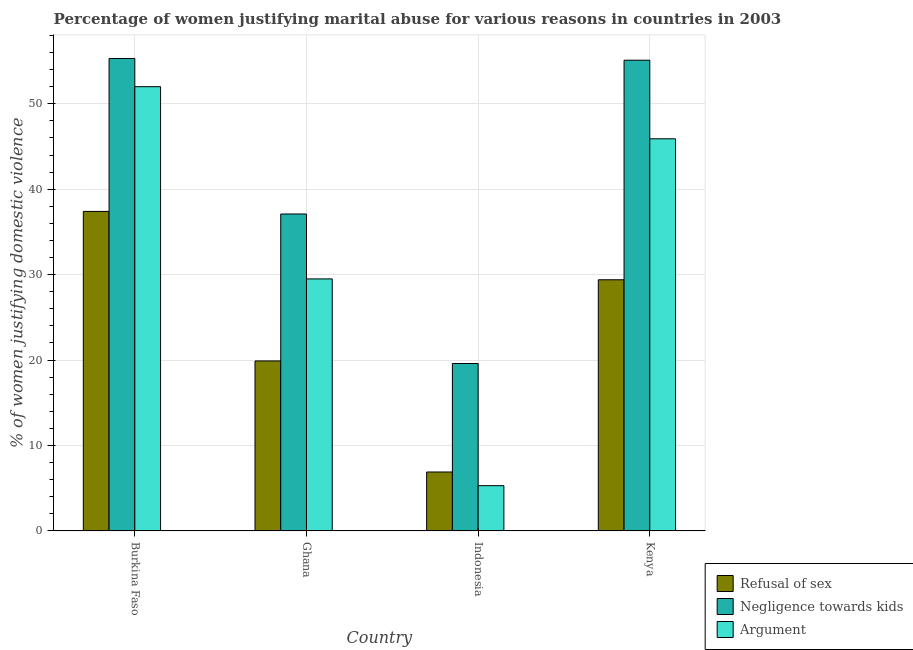Are the number of bars per tick equal to the number of legend labels?
Your response must be concise. Yes. Are the number of bars on each tick of the X-axis equal?
Your response must be concise. Yes. How many bars are there on the 1st tick from the left?
Provide a short and direct response. 3. How many bars are there on the 4th tick from the right?
Offer a very short reply. 3. What is the label of the 2nd group of bars from the left?
Make the answer very short. Ghana. Across all countries, what is the maximum percentage of women justifying domestic violence due to refusal of sex?
Provide a short and direct response. 37.4. In which country was the percentage of women justifying domestic violence due to refusal of sex maximum?
Provide a short and direct response. Burkina Faso. What is the total percentage of women justifying domestic violence due to refusal of sex in the graph?
Ensure brevity in your answer.  93.6. What is the difference between the percentage of women justifying domestic violence due to refusal of sex in Ghana and that in Kenya?
Offer a terse response. -9.5. What is the difference between the percentage of women justifying domestic violence due to arguments in Burkina Faso and the percentage of women justifying domestic violence due to negligence towards kids in Kenya?
Keep it short and to the point. -3.1. What is the average percentage of women justifying domestic violence due to negligence towards kids per country?
Your response must be concise. 41.77. What is the difference between the percentage of women justifying domestic violence due to refusal of sex and percentage of women justifying domestic violence due to negligence towards kids in Kenya?
Give a very brief answer. -25.7. What is the ratio of the percentage of women justifying domestic violence due to negligence towards kids in Indonesia to that in Kenya?
Offer a terse response. 0.36. Is the percentage of women justifying domestic violence due to negligence towards kids in Burkina Faso less than that in Indonesia?
Ensure brevity in your answer.  No. What is the difference between the highest and the second highest percentage of women justifying domestic violence due to negligence towards kids?
Give a very brief answer. 0.2. What is the difference between the highest and the lowest percentage of women justifying domestic violence due to negligence towards kids?
Your answer should be compact. 35.7. In how many countries, is the percentage of women justifying domestic violence due to arguments greater than the average percentage of women justifying domestic violence due to arguments taken over all countries?
Provide a short and direct response. 2. What does the 2nd bar from the left in Ghana represents?
Offer a very short reply. Negligence towards kids. What does the 1st bar from the right in Kenya represents?
Offer a terse response. Argument. Is it the case that in every country, the sum of the percentage of women justifying domestic violence due to refusal of sex and percentage of women justifying domestic violence due to negligence towards kids is greater than the percentage of women justifying domestic violence due to arguments?
Provide a short and direct response. Yes. How many countries are there in the graph?
Offer a very short reply. 4. Does the graph contain any zero values?
Offer a terse response. No. Does the graph contain grids?
Your answer should be compact. Yes. What is the title of the graph?
Provide a succinct answer. Percentage of women justifying marital abuse for various reasons in countries in 2003. Does "Taxes on international trade" appear as one of the legend labels in the graph?
Give a very brief answer. No. What is the label or title of the X-axis?
Provide a short and direct response. Country. What is the label or title of the Y-axis?
Make the answer very short. % of women justifying domestic violence. What is the % of women justifying domestic violence in Refusal of sex in Burkina Faso?
Make the answer very short. 37.4. What is the % of women justifying domestic violence of Negligence towards kids in Burkina Faso?
Give a very brief answer. 55.3. What is the % of women justifying domestic violence of Refusal of sex in Ghana?
Provide a short and direct response. 19.9. What is the % of women justifying domestic violence in Negligence towards kids in Ghana?
Give a very brief answer. 37.1. What is the % of women justifying domestic violence in Argument in Ghana?
Your answer should be compact. 29.5. What is the % of women justifying domestic violence in Negligence towards kids in Indonesia?
Offer a very short reply. 19.6. What is the % of women justifying domestic violence in Refusal of sex in Kenya?
Keep it short and to the point. 29.4. What is the % of women justifying domestic violence of Negligence towards kids in Kenya?
Make the answer very short. 55.1. What is the % of women justifying domestic violence in Argument in Kenya?
Make the answer very short. 45.9. Across all countries, what is the maximum % of women justifying domestic violence in Refusal of sex?
Offer a terse response. 37.4. Across all countries, what is the maximum % of women justifying domestic violence of Negligence towards kids?
Offer a terse response. 55.3. Across all countries, what is the maximum % of women justifying domestic violence of Argument?
Provide a short and direct response. 52. Across all countries, what is the minimum % of women justifying domestic violence in Negligence towards kids?
Offer a terse response. 19.6. Across all countries, what is the minimum % of women justifying domestic violence in Argument?
Make the answer very short. 5.3. What is the total % of women justifying domestic violence in Refusal of sex in the graph?
Provide a short and direct response. 93.6. What is the total % of women justifying domestic violence of Negligence towards kids in the graph?
Keep it short and to the point. 167.1. What is the total % of women justifying domestic violence of Argument in the graph?
Your answer should be very brief. 132.7. What is the difference between the % of women justifying domestic violence of Refusal of sex in Burkina Faso and that in Ghana?
Offer a very short reply. 17.5. What is the difference between the % of women justifying domestic violence in Negligence towards kids in Burkina Faso and that in Ghana?
Ensure brevity in your answer.  18.2. What is the difference between the % of women justifying domestic violence in Refusal of sex in Burkina Faso and that in Indonesia?
Your answer should be very brief. 30.5. What is the difference between the % of women justifying domestic violence in Negligence towards kids in Burkina Faso and that in Indonesia?
Provide a succinct answer. 35.7. What is the difference between the % of women justifying domestic violence of Argument in Burkina Faso and that in Indonesia?
Give a very brief answer. 46.7. What is the difference between the % of women justifying domestic violence in Argument in Burkina Faso and that in Kenya?
Make the answer very short. 6.1. What is the difference between the % of women justifying domestic violence of Refusal of sex in Ghana and that in Indonesia?
Keep it short and to the point. 13. What is the difference between the % of women justifying domestic violence in Negligence towards kids in Ghana and that in Indonesia?
Keep it short and to the point. 17.5. What is the difference between the % of women justifying domestic violence of Argument in Ghana and that in Indonesia?
Your answer should be compact. 24.2. What is the difference between the % of women justifying domestic violence in Refusal of sex in Ghana and that in Kenya?
Keep it short and to the point. -9.5. What is the difference between the % of women justifying domestic violence in Argument in Ghana and that in Kenya?
Make the answer very short. -16.4. What is the difference between the % of women justifying domestic violence in Refusal of sex in Indonesia and that in Kenya?
Ensure brevity in your answer.  -22.5. What is the difference between the % of women justifying domestic violence in Negligence towards kids in Indonesia and that in Kenya?
Your answer should be compact. -35.5. What is the difference between the % of women justifying domestic violence in Argument in Indonesia and that in Kenya?
Your answer should be very brief. -40.6. What is the difference between the % of women justifying domestic violence in Refusal of sex in Burkina Faso and the % of women justifying domestic violence in Argument in Ghana?
Your response must be concise. 7.9. What is the difference between the % of women justifying domestic violence of Negligence towards kids in Burkina Faso and the % of women justifying domestic violence of Argument in Ghana?
Make the answer very short. 25.8. What is the difference between the % of women justifying domestic violence in Refusal of sex in Burkina Faso and the % of women justifying domestic violence in Argument in Indonesia?
Make the answer very short. 32.1. What is the difference between the % of women justifying domestic violence of Negligence towards kids in Burkina Faso and the % of women justifying domestic violence of Argument in Indonesia?
Keep it short and to the point. 50. What is the difference between the % of women justifying domestic violence in Refusal of sex in Burkina Faso and the % of women justifying domestic violence in Negligence towards kids in Kenya?
Keep it short and to the point. -17.7. What is the difference between the % of women justifying domestic violence of Refusal of sex in Burkina Faso and the % of women justifying domestic violence of Argument in Kenya?
Give a very brief answer. -8.5. What is the difference between the % of women justifying domestic violence in Negligence towards kids in Burkina Faso and the % of women justifying domestic violence in Argument in Kenya?
Your answer should be very brief. 9.4. What is the difference between the % of women justifying domestic violence of Refusal of sex in Ghana and the % of women justifying domestic violence of Argument in Indonesia?
Provide a short and direct response. 14.6. What is the difference between the % of women justifying domestic violence of Negligence towards kids in Ghana and the % of women justifying domestic violence of Argument in Indonesia?
Your answer should be very brief. 31.8. What is the difference between the % of women justifying domestic violence in Refusal of sex in Ghana and the % of women justifying domestic violence in Negligence towards kids in Kenya?
Provide a short and direct response. -35.2. What is the difference between the % of women justifying domestic violence of Refusal of sex in Ghana and the % of women justifying domestic violence of Argument in Kenya?
Provide a succinct answer. -26. What is the difference between the % of women justifying domestic violence of Refusal of sex in Indonesia and the % of women justifying domestic violence of Negligence towards kids in Kenya?
Ensure brevity in your answer.  -48.2. What is the difference between the % of women justifying domestic violence in Refusal of sex in Indonesia and the % of women justifying domestic violence in Argument in Kenya?
Give a very brief answer. -39. What is the difference between the % of women justifying domestic violence of Negligence towards kids in Indonesia and the % of women justifying domestic violence of Argument in Kenya?
Your response must be concise. -26.3. What is the average % of women justifying domestic violence in Refusal of sex per country?
Your answer should be very brief. 23.4. What is the average % of women justifying domestic violence in Negligence towards kids per country?
Give a very brief answer. 41.77. What is the average % of women justifying domestic violence of Argument per country?
Your response must be concise. 33.17. What is the difference between the % of women justifying domestic violence in Refusal of sex and % of women justifying domestic violence in Negligence towards kids in Burkina Faso?
Give a very brief answer. -17.9. What is the difference between the % of women justifying domestic violence of Refusal of sex and % of women justifying domestic violence of Argument in Burkina Faso?
Provide a short and direct response. -14.6. What is the difference between the % of women justifying domestic violence in Refusal of sex and % of women justifying domestic violence in Negligence towards kids in Ghana?
Offer a terse response. -17.2. What is the difference between the % of women justifying domestic violence of Refusal of sex and % of women justifying domestic violence of Argument in Ghana?
Keep it short and to the point. -9.6. What is the difference between the % of women justifying domestic violence of Refusal of sex and % of women justifying domestic violence of Negligence towards kids in Kenya?
Ensure brevity in your answer.  -25.7. What is the difference between the % of women justifying domestic violence of Refusal of sex and % of women justifying domestic violence of Argument in Kenya?
Offer a very short reply. -16.5. What is the ratio of the % of women justifying domestic violence in Refusal of sex in Burkina Faso to that in Ghana?
Your answer should be very brief. 1.88. What is the ratio of the % of women justifying domestic violence of Negligence towards kids in Burkina Faso to that in Ghana?
Your answer should be compact. 1.49. What is the ratio of the % of women justifying domestic violence of Argument in Burkina Faso to that in Ghana?
Your answer should be compact. 1.76. What is the ratio of the % of women justifying domestic violence of Refusal of sex in Burkina Faso to that in Indonesia?
Make the answer very short. 5.42. What is the ratio of the % of women justifying domestic violence in Negligence towards kids in Burkina Faso to that in Indonesia?
Offer a very short reply. 2.82. What is the ratio of the % of women justifying domestic violence of Argument in Burkina Faso to that in Indonesia?
Your answer should be compact. 9.81. What is the ratio of the % of women justifying domestic violence of Refusal of sex in Burkina Faso to that in Kenya?
Your answer should be very brief. 1.27. What is the ratio of the % of women justifying domestic violence of Argument in Burkina Faso to that in Kenya?
Provide a short and direct response. 1.13. What is the ratio of the % of women justifying domestic violence of Refusal of sex in Ghana to that in Indonesia?
Keep it short and to the point. 2.88. What is the ratio of the % of women justifying domestic violence of Negligence towards kids in Ghana to that in Indonesia?
Your response must be concise. 1.89. What is the ratio of the % of women justifying domestic violence of Argument in Ghana to that in Indonesia?
Provide a succinct answer. 5.57. What is the ratio of the % of women justifying domestic violence in Refusal of sex in Ghana to that in Kenya?
Ensure brevity in your answer.  0.68. What is the ratio of the % of women justifying domestic violence in Negligence towards kids in Ghana to that in Kenya?
Provide a succinct answer. 0.67. What is the ratio of the % of women justifying domestic violence of Argument in Ghana to that in Kenya?
Keep it short and to the point. 0.64. What is the ratio of the % of women justifying domestic violence of Refusal of sex in Indonesia to that in Kenya?
Give a very brief answer. 0.23. What is the ratio of the % of women justifying domestic violence in Negligence towards kids in Indonesia to that in Kenya?
Provide a succinct answer. 0.36. What is the ratio of the % of women justifying domestic violence in Argument in Indonesia to that in Kenya?
Give a very brief answer. 0.12. What is the difference between the highest and the second highest % of women justifying domestic violence of Refusal of sex?
Offer a terse response. 8. What is the difference between the highest and the lowest % of women justifying domestic violence in Refusal of sex?
Ensure brevity in your answer.  30.5. What is the difference between the highest and the lowest % of women justifying domestic violence in Negligence towards kids?
Ensure brevity in your answer.  35.7. What is the difference between the highest and the lowest % of women justifying domestic violence in Argument?
Make the answer very short. 46.7. 